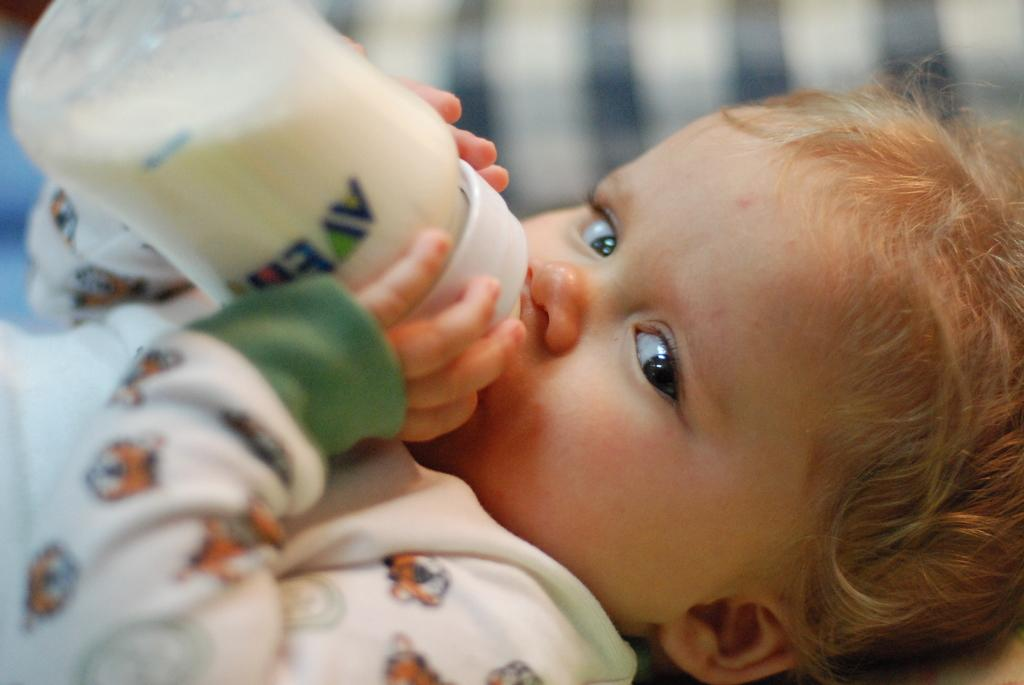What is the main subject of the image? The main subject of the image is a small baby. What is the baby doing in the image? The baby is lying down and drinking milk from a bottle. What direction is the baby looking in the image? The baby is looking towards the camera. What type of noise can be heard coming from the baby in the image? There is no indication of any noise in the image, as it only shows a baby lying down and drinking milk from a bottle. 